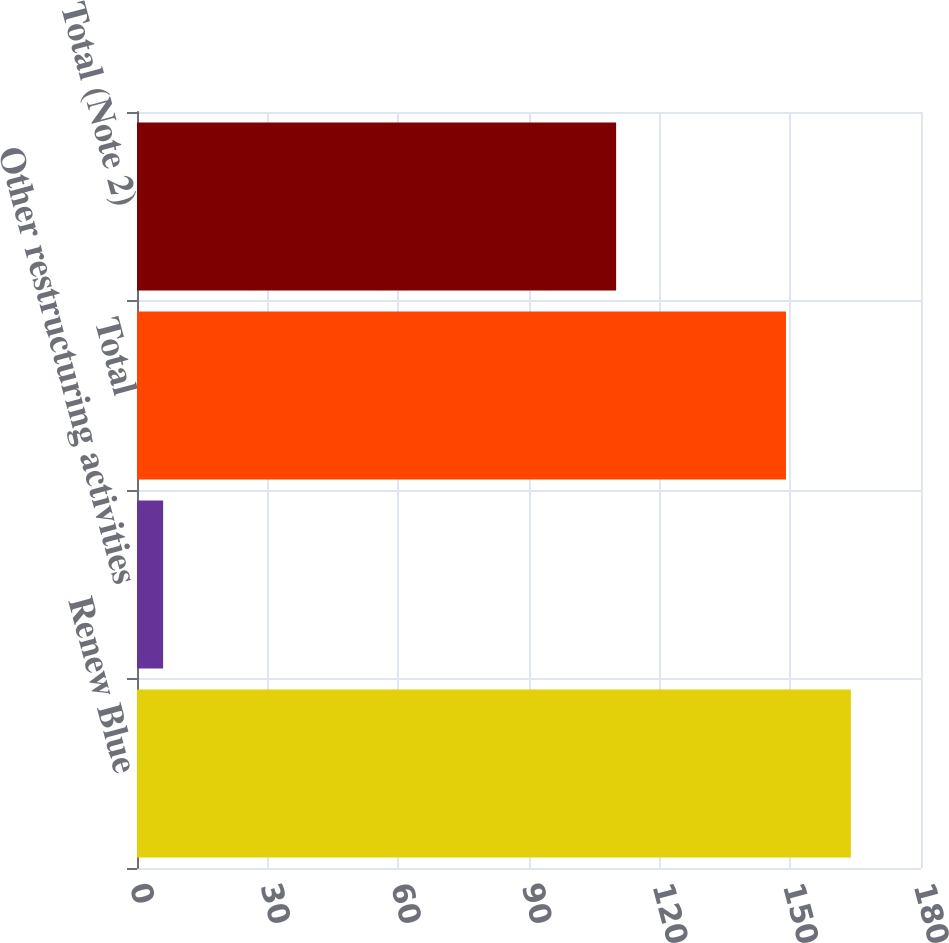Convert chart to OTSL. <chart><loc_0><loc_0><loc_500><loc_500><bar_chart><fcel>Renew Blue<fcel>Other restructuring activities<fcel>Total<fcel>Total (Note 2)<nl><fcel>163.9<fcel>6<fcel>149<fcel>110<nl></chart> 